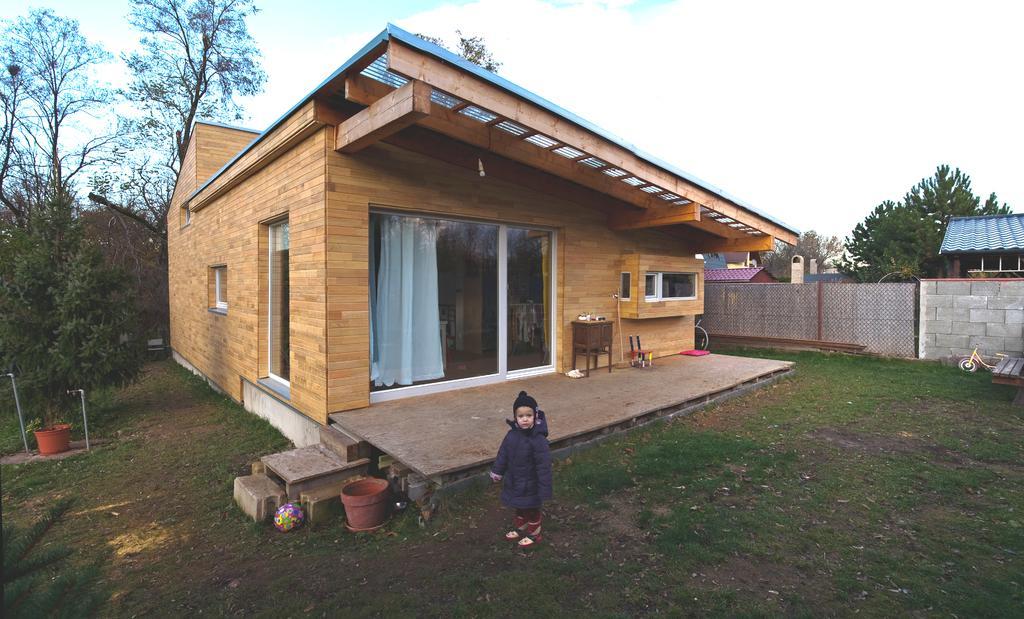Please provide a concise description of this image. In this picture there is a kid standing and we can see grass, house, poles, ball, bicycle, wall, pots and objects. In the background of the image we can see trees, houses and sky. 